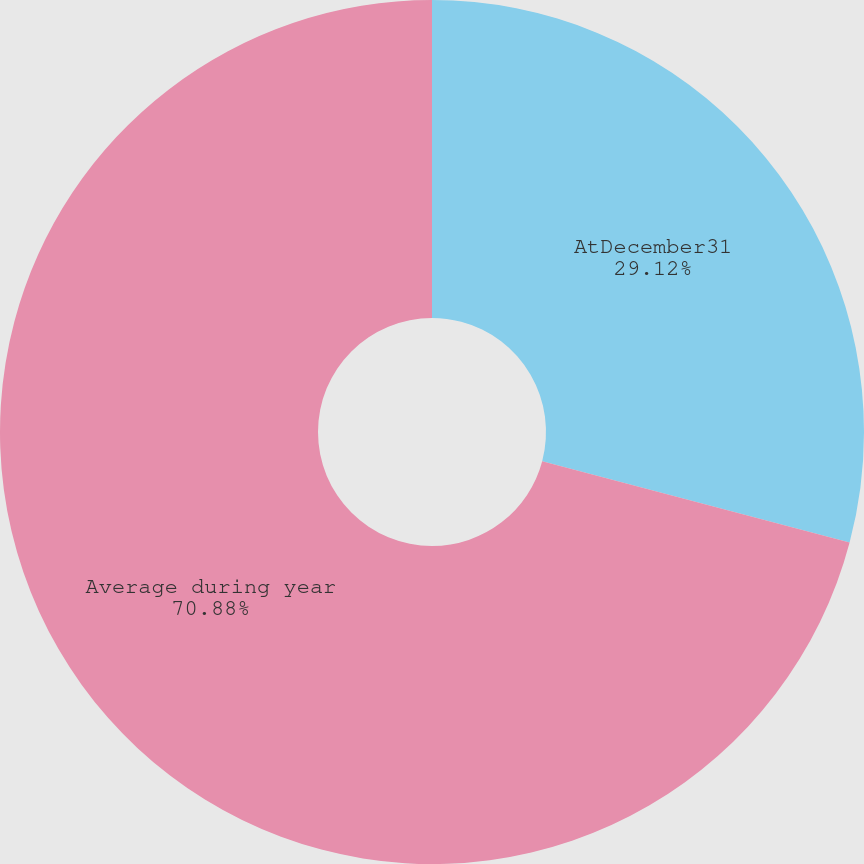Convert chart. <chart><loc_0><loc_0><loc_500><loc_500><pie_chart><fcel>AtDecember31<fcel>Average during year<nl><fcel>29.12%<fcel>70.88%<nl></chart> 